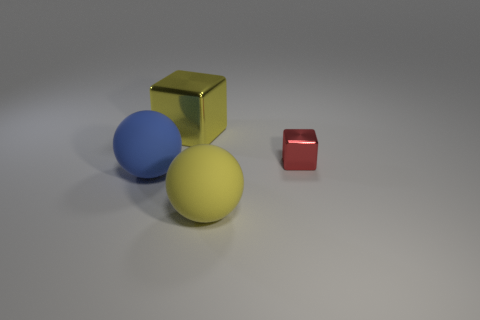Add 3 tiny rubber cylinders. How many objects exist? 7 Subtract all tiny blocks. Subtract all blue things. How many objects are left? 2 Add 3 red shiny cubes. How many red shiny cubes are left? 4 Add 1 red shiny cubes. How many red shiny cubes exist? 2 Subtract 0 brown blocks. How many objects are left? 4 